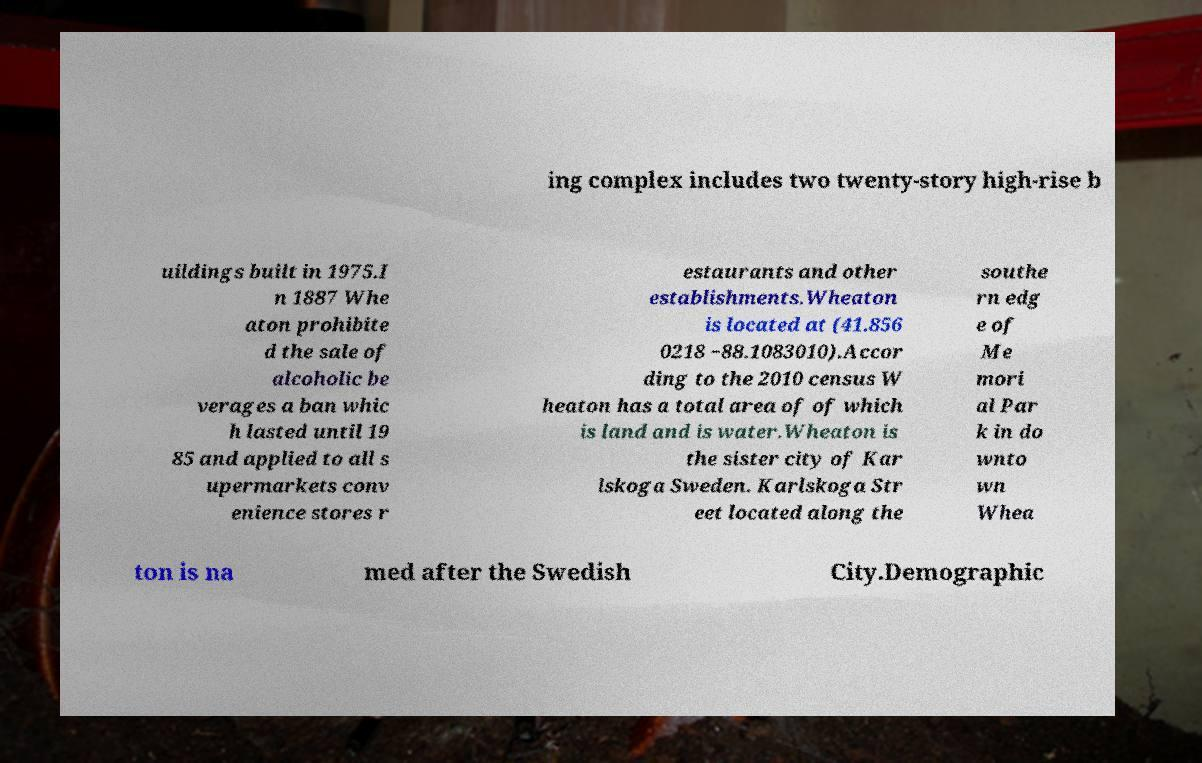Can you accurately transcribe the text from the provided image for me? ing complex includes two twenty-story high-rise b uildings built in 1975.I n 1887 Whe aton prohibite d the sale of alcoholic be verages a ban whic h lasted until 19 85 and applied to all s upermarkets conv enience stores r estaurants and other establishments.Wheaton is located at (41.856 0218 −88.1083010).Accor ding to the 2010 census W heaton has a total area of of which is land and is water.Wheaton is the sister city of Kar lskoga Sweden. Karlskoga Str eet located along the southe rn edg e of Me mori al Par k in do wnto wn Whea ton is na med after the Swedish City.Demographic 